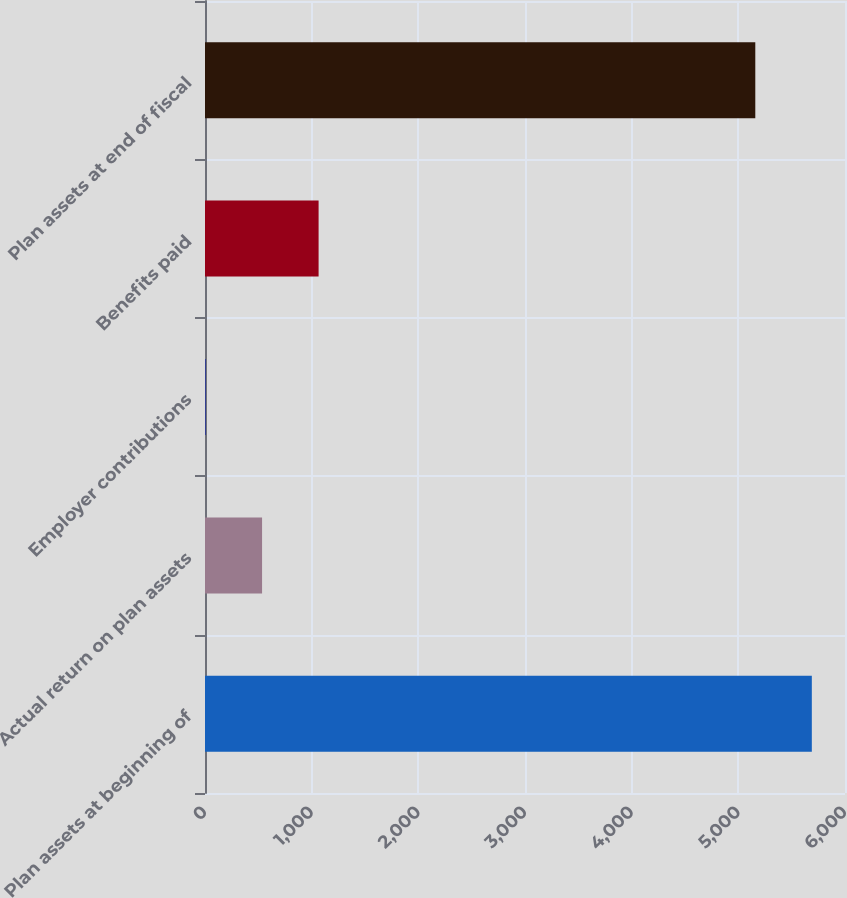Convert chart. <chart><loc_0><loc_0><loc_500><loc_500><bar_chart><fcel>Plan assets at beginning of<fcel>Actual return on plan assets<fcel>Employer contributions<fcel>Benefits paid<fcel>Plan assets at end of fiscal<nl><fcel>5689<fcel>535<fcel>5<fcel>1065<fcel>5159<nl></chart> 